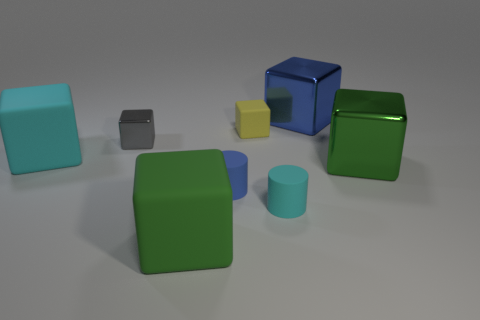How many objects are there in total? There are a total of seven objects in the image, consisting of different shapes and colors. Can you describe the shapes present? Certainly! The objects include cubes, cuboids, and a cylinder. There are two cubes, three cuboids of varying sizes, and two objects that appear to be cylindrical. 